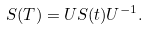Convert formula to latex. <formula><loc_0><loc_0><loc_500><loc_500>S ( T ) = U S ( t ) U ^ { - 1 } .</formula> 